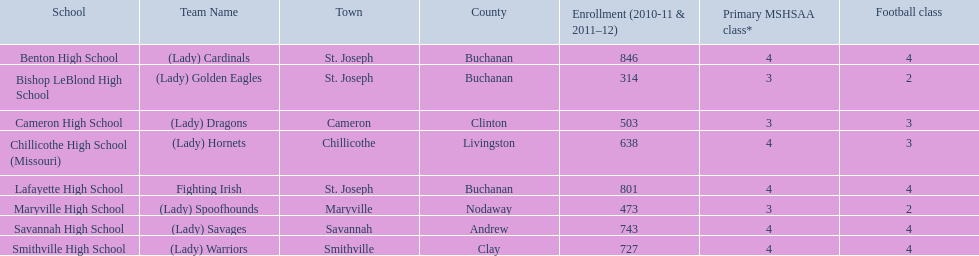What are all the academic institutions? Benton High School, Bishop LeBlond High School, Cameron High School, Chillicothe High School (Missouri), Lafayette High School, Maryville High School, Savannah High School, Smithville High School. How many football programs do they provide? 4, 2, 3, 3, 4, 2, 4, 4. What about their enrolment? 846, 314, 503, 638, 801, 473, 743, 727. Which institutions have 3 football programs? Cameron High School, Chillicothe High School (Missouri). And of those institutions, which has 638 pupils? Chillicothe High School (Missouri). 